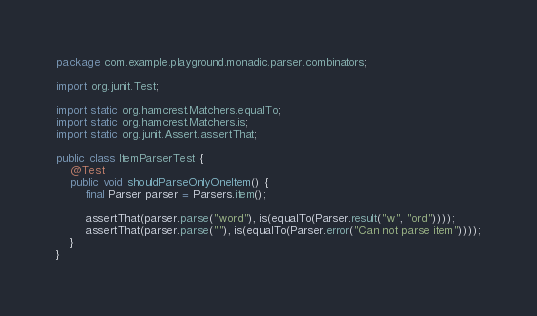<code> <loc_0><loc_0><loc_500><loc_500><_Java_>package com.example.playground.monadic.parser.combinators;

import org.junit.Test;

import static org.hamcrest.Matchers.equalTo;
import static org.hamcrest.Matchers.is;
import static org.junit.Assert.assertThat;

public class ItemParserTest {
    @Test
    public void shouldParseOnlyOneItem() {
        final Parser parser = Parsers.item();

        assertThat(parser.parse("word"), is(equalTo(Parser.result("w", "ord"))));
        assertThat(parser.parse(""), is(equalTo(Parser.error("Can not parse item"))));
    }
}
</code> 